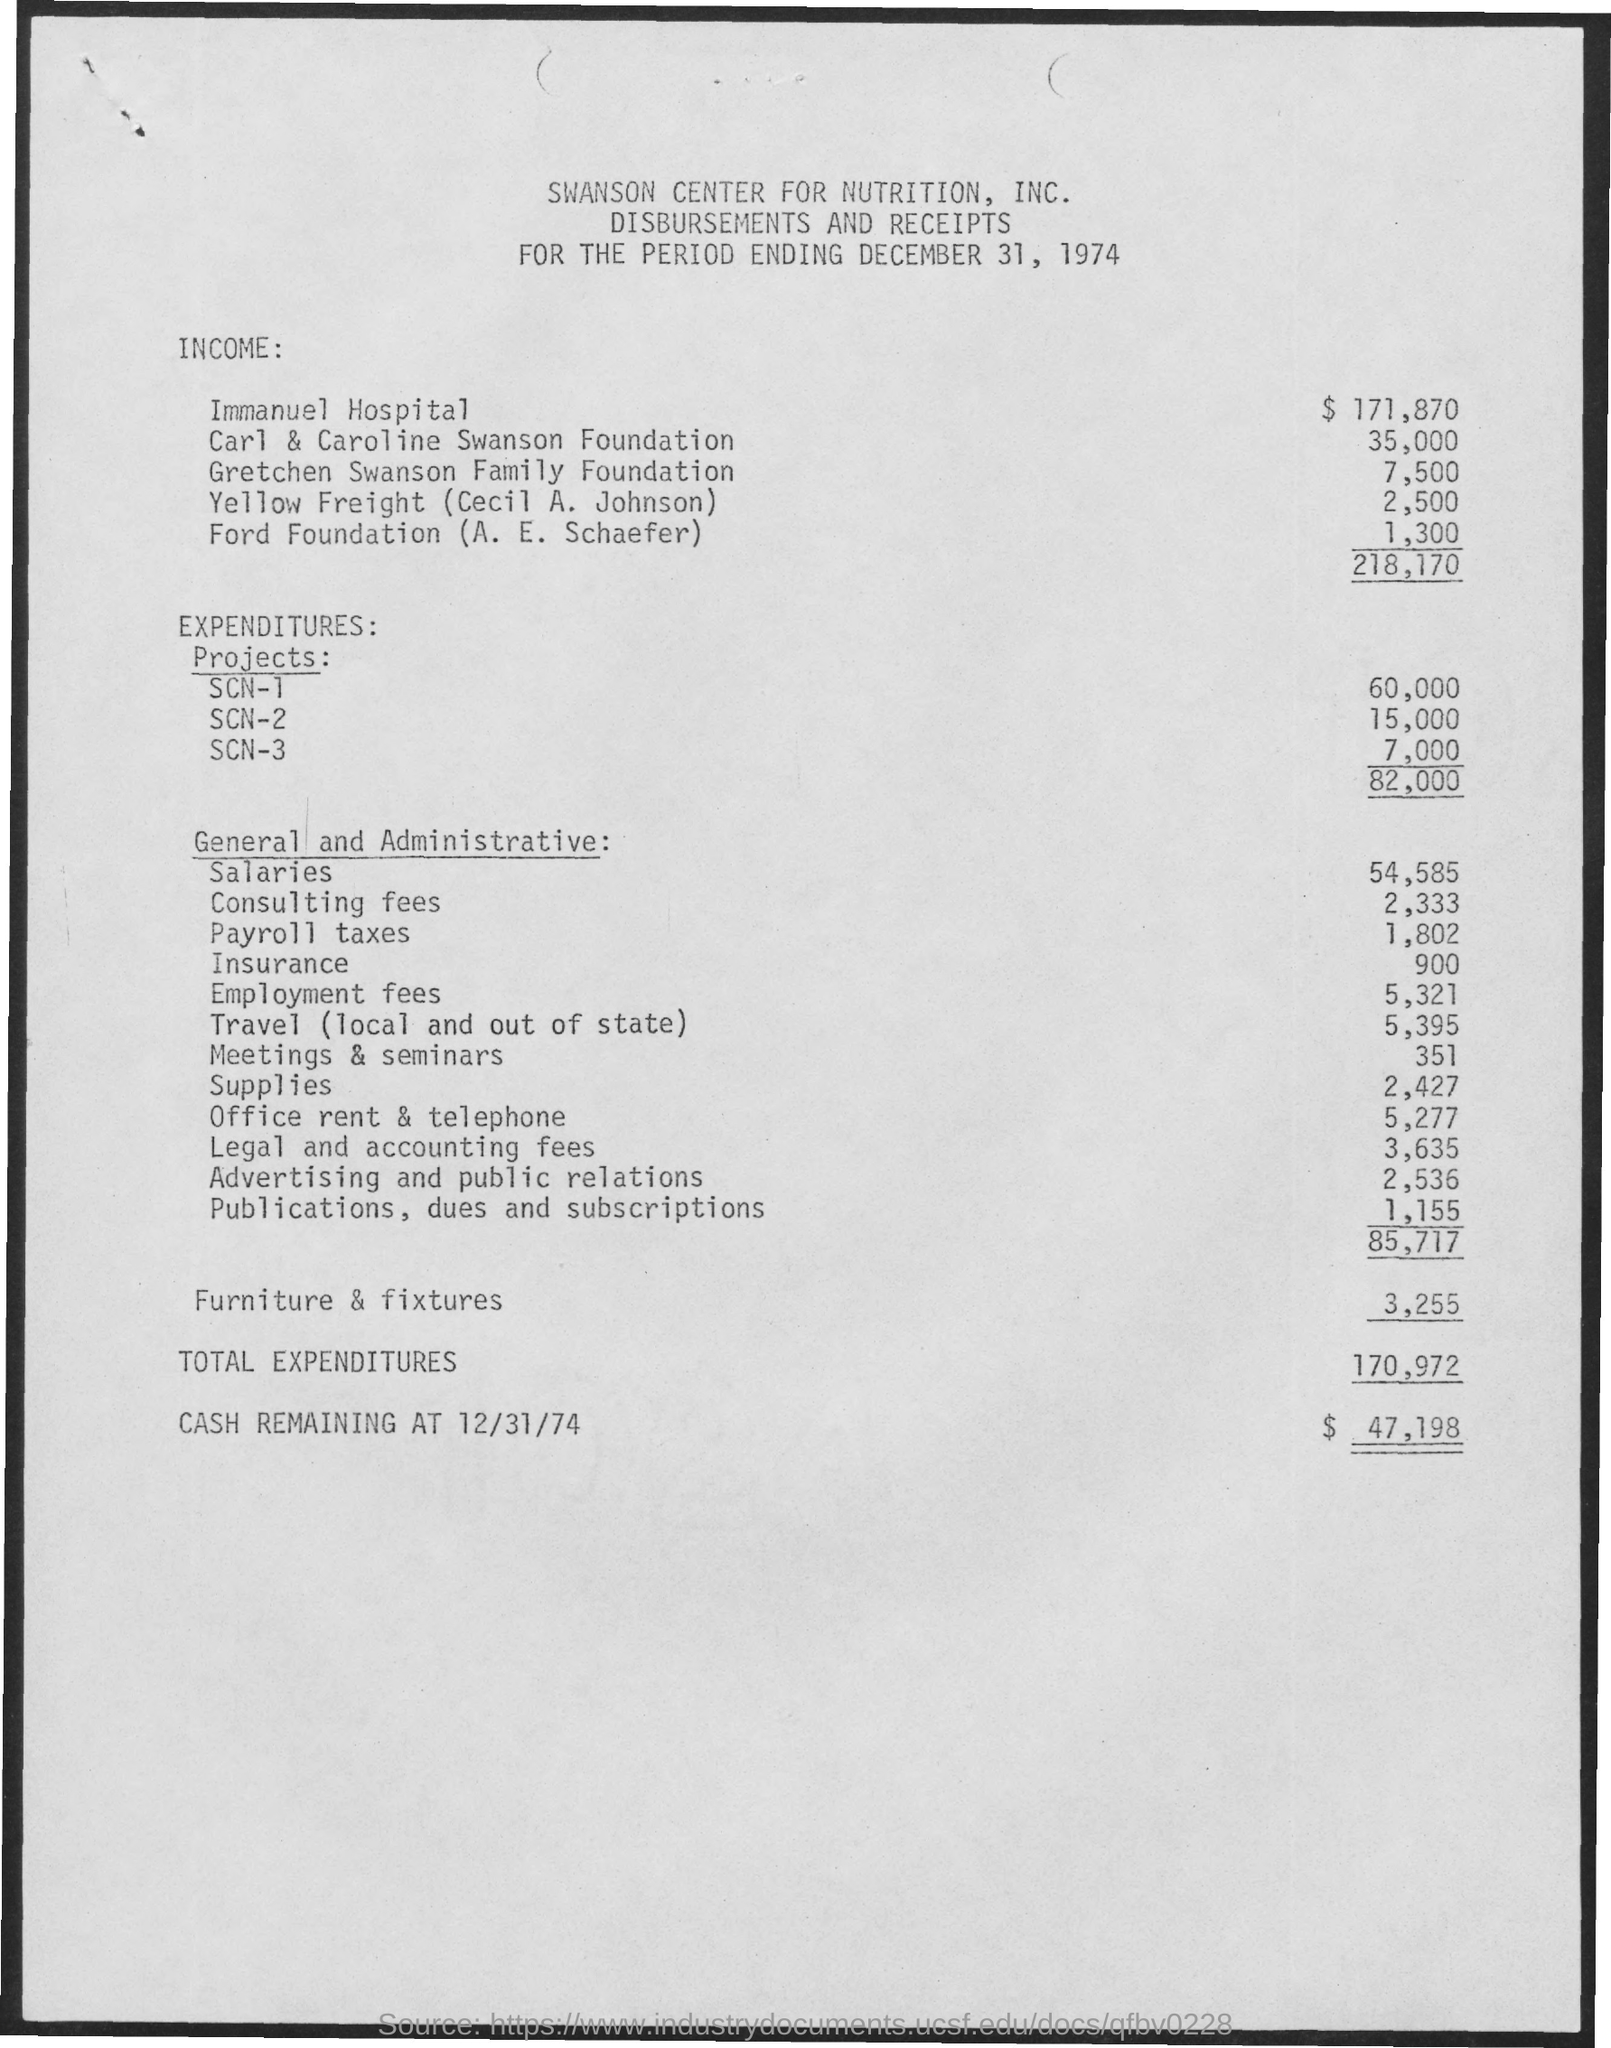What is the Income for Immanuel Hospital?
Give a very brief answer. 171,870. What is the Income for Carl & Caroline Swanson Foundation?
Make the answer very short. 35,000. What is the Income for Gretchen Swanson family Foundation?
Offer a very short reply. 7,500. What is the Income for Yello Freight (Cecil A. Johnson)?
Your answer should be compact. 2,500. What is the Income for Ford Foundation (A. E. Schaefer)?
Keep it short and to the point. 1,300. What is the Expenditures for Project SCN-1?
Your answer should be very brief. 60,000. What is the Expenditures for Project SCN-2?
Ensure brevity in your answer.  15,000. What is the Expenditures for Project SCN-3?
Your response must be concise. 7,000. What is the General and administrative Salaries?
Make the answer very short. 54,585. What is the General and administrative Insurance?
Provide a short and direct response. 900. 